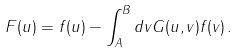Convert formula to latex. <formula><loc_0><loc_0><loc_500><loc_500>F ( u ) = f ( u ) - \int _ { A } ^ { B } d v G ( u , v ) f ( v ) \, .</formula> 